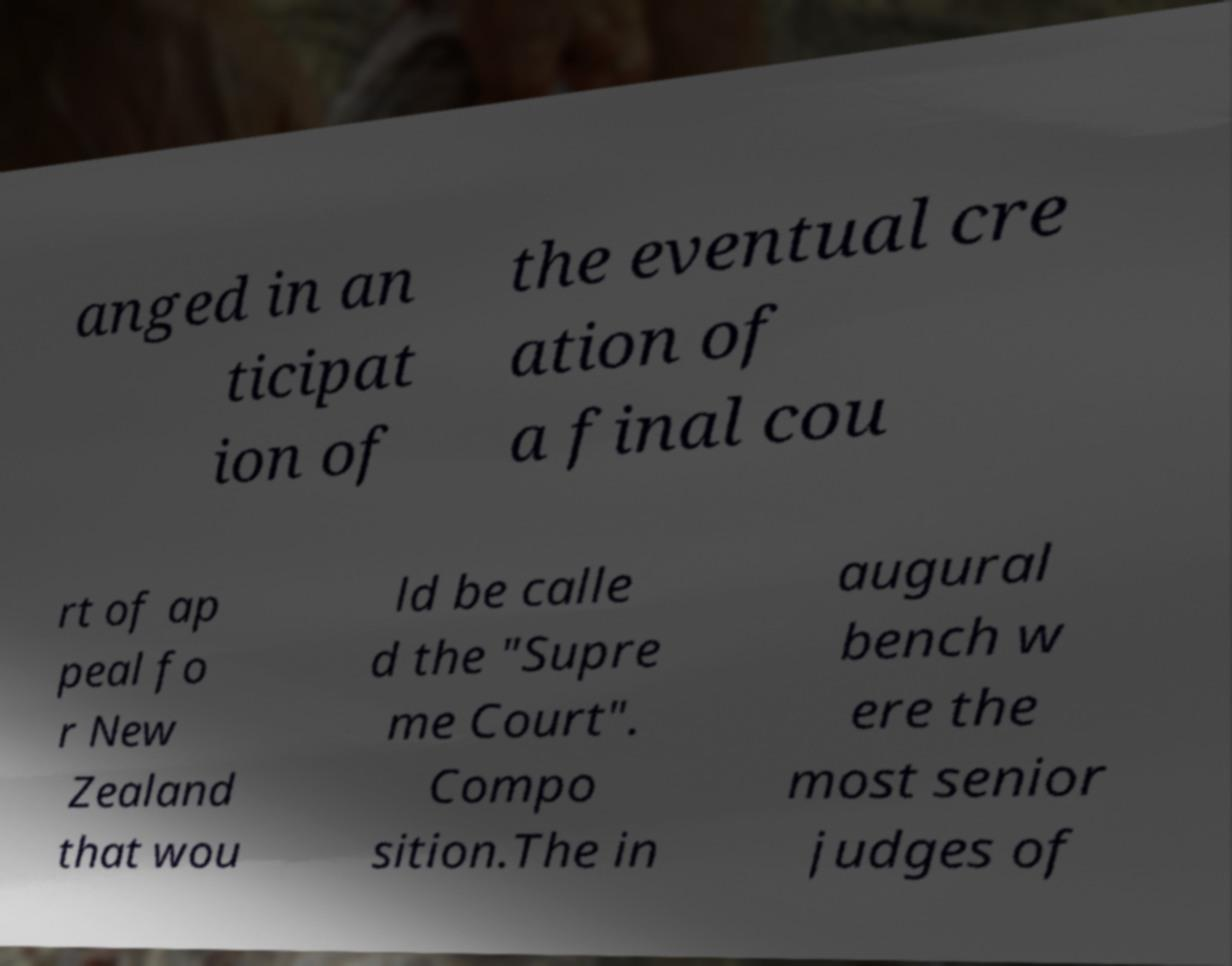Please identify and transcribe the text found in this image. anged in an ticipat ion of the eventual cre ation of a final cou rt of ap peal fo r New Zealand that wou ld be calle d the "Supre me Court". Compo sition.The in augural bench w ere the most senior judges of 